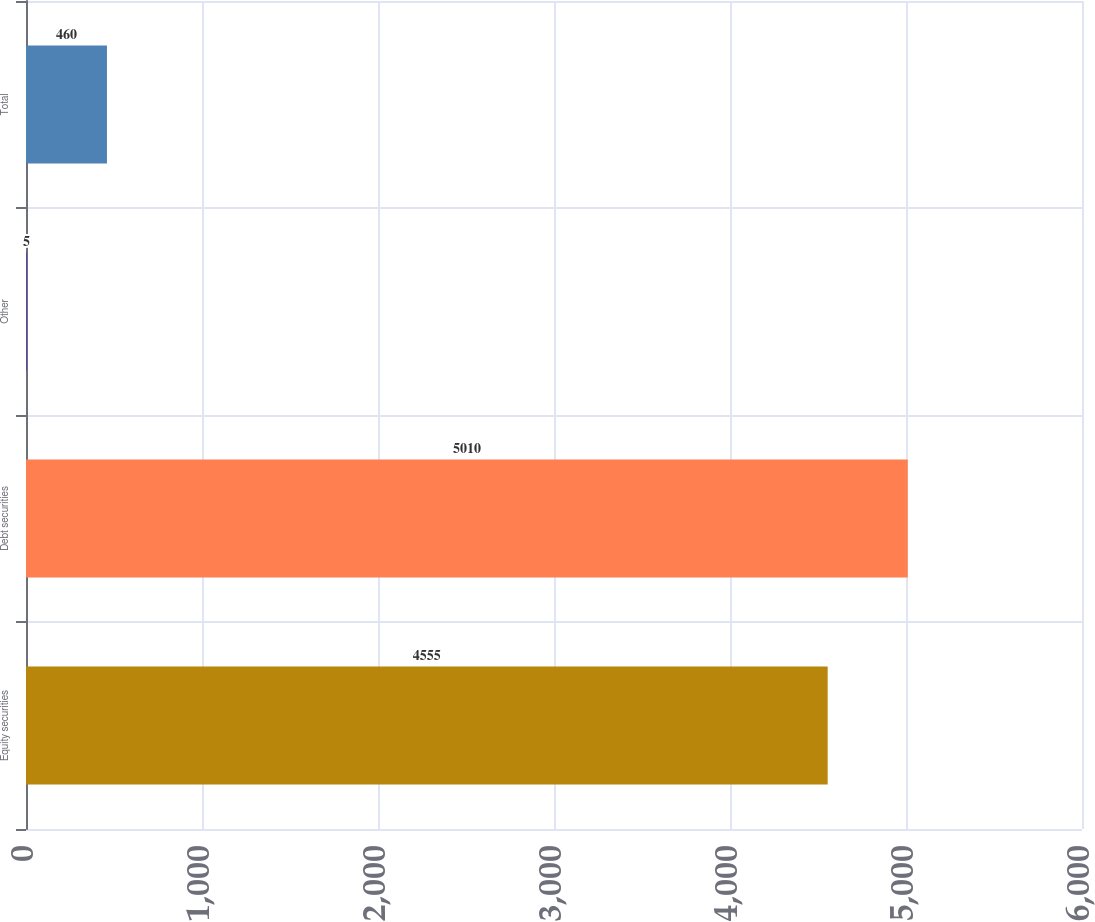<chart> <loc_0><loc_0><loc_500><loc_500><bar_chart><fcel>Equity securities<fcel>Debt securities<fcel>Other<fcel>Total<nl><fcel>4555<fcel>5010<fcel>5<fcel>460<nl></chart> 